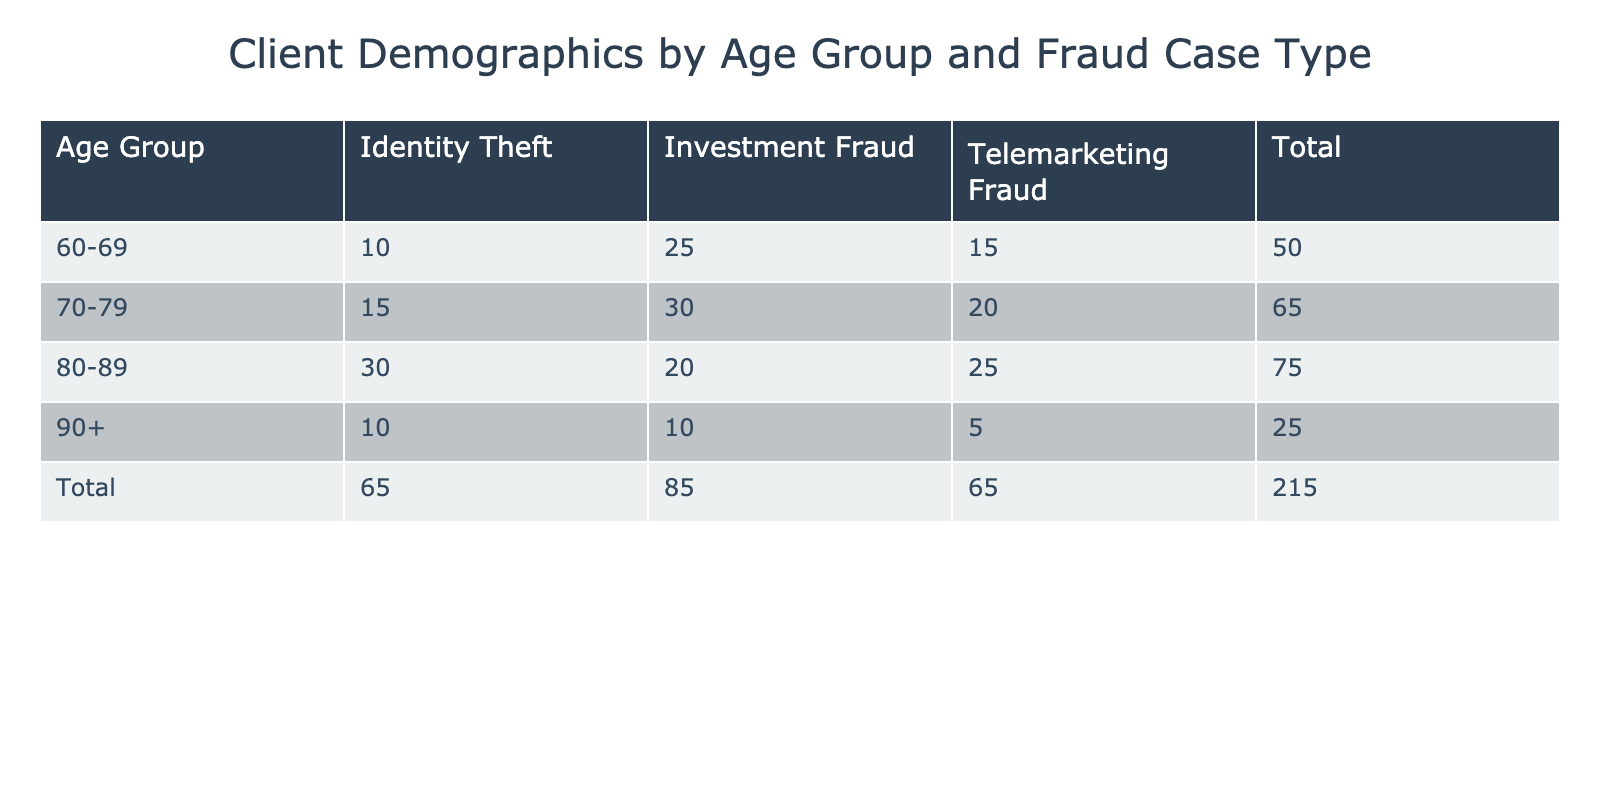What is the total number of clients aged 60-69 facing Investment Fraud? Referring to the table, the count of clients aged 60-69 for Investment Fraud is directly stated as 25.
Answer: 25 Which age group has the highest total number of clients? Adding the client counts for each age group: 60-69: 50, 70-79: 65, 80-89: 75, 90+: 25. The age group 80-89 has the highest total of 75.
Answer: 80-89 How many clients aged 80-89 are victims of Telemarketing Fraud? The table specifies that there are 25 clients aged 80-89 impacted by Telemarketing Fraud.
Answer: 25 Is the number of clients aged 70-79 for Identity Theft greater than those aged 90+ for the same type? For Identity Theft, clients aged 70-79 total 15 while those aged 90+ total 10. Since 15 is greater than 10, the answer is yes.
Answer: Yes What is the combined total of clients aged 60-69 and 70-79 who are victims of Investment Fraud? Adding the counts for Investment Fraud: clients aged 60-69 (25) and 70-79 (30) results in a combined total of 55.
Answer: 55 How many more clients aged 80-89 are affected by Identity Theft compared to those aged 60-69? clients aged 80-89: 30 and those aged 60-69: 10. The difference is 30 - 10 = 20 more clients aged 80-89 affected.
Answer: 20 Which age group has fewer clients for Telemarketing Fraud: 60-69 or 90+? The table shows 15 clients aged 60-69 and 5 clients aged 90+. Since 5 is fewer than 15, the answer is the age group 90+.
Answer: 90+ How many clients in total are victims of fraud across all age groups? Summing all the counts gives: 25 + 15 + 10 + 30 + 20 + 15 + 20 + 25 + 30 + 10 + 5 + 10 =  220 total clients across all age groups.
Answer: 220 Which age group has the highest number of clients for Telemarketing Fraud? Examining the Telemarketing Fraud column: 15 (60-69), 20 (70-79), 25 (80-89), and 5 (90+). The age group 80-89 has the highest count of 25.
Answer: 80-89 